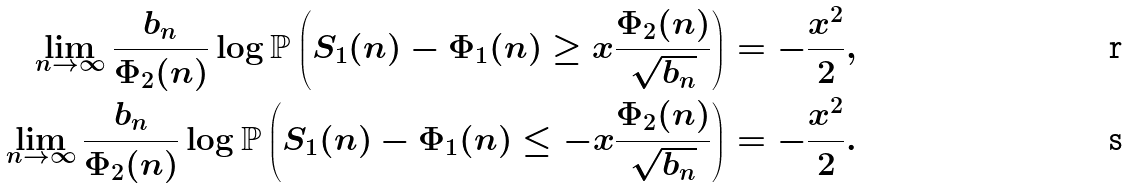<formula> <loc_0><loc_0><loc_500><loc_500>\lim _ { n \rightarrow \infty } \frac { b _ { n } } { \Phi _ { 2 } ( n ) } \log \mathbb { P } \left ( S _ { 1 } ( n ) - \Phi _ { 1 } ( n ) \geq x \frac { \Phi _ { 2 } ( n ) } { \sqrt { b _ { n } } } \right ) & = - \frac { x ^ { 2 } } { 2 } , \\ \lim _ { n \rightarrow \infty } \frac { b _ { n } } { \Phi _ { 2 } ( n ) } \log \mathbb { P } \left ( S _ { 1 } ( n ) - \Phi _ { 1 } ( n ) \leq - x \frac { \Phi _ { 2 } ( n ) } { \sqrt { b _ { n } } } \right ) & = - \frac { x ^ { 2 } } { 2 } .</formula> 